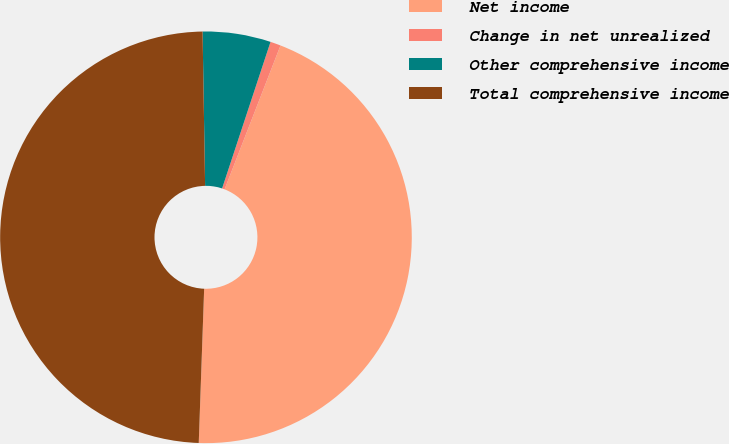<chart> <loc_0><loc_0><loc_500><loc_500><pie_chart><fcel>Net income<fcel>Change in net unrealized<fcel>Other comprehensive income<fcel>Total comprehensive income<nl><fcel>44.66%<fcel>0.82%<fcel>5.34%<fcel>49.18%<nl></chart> 